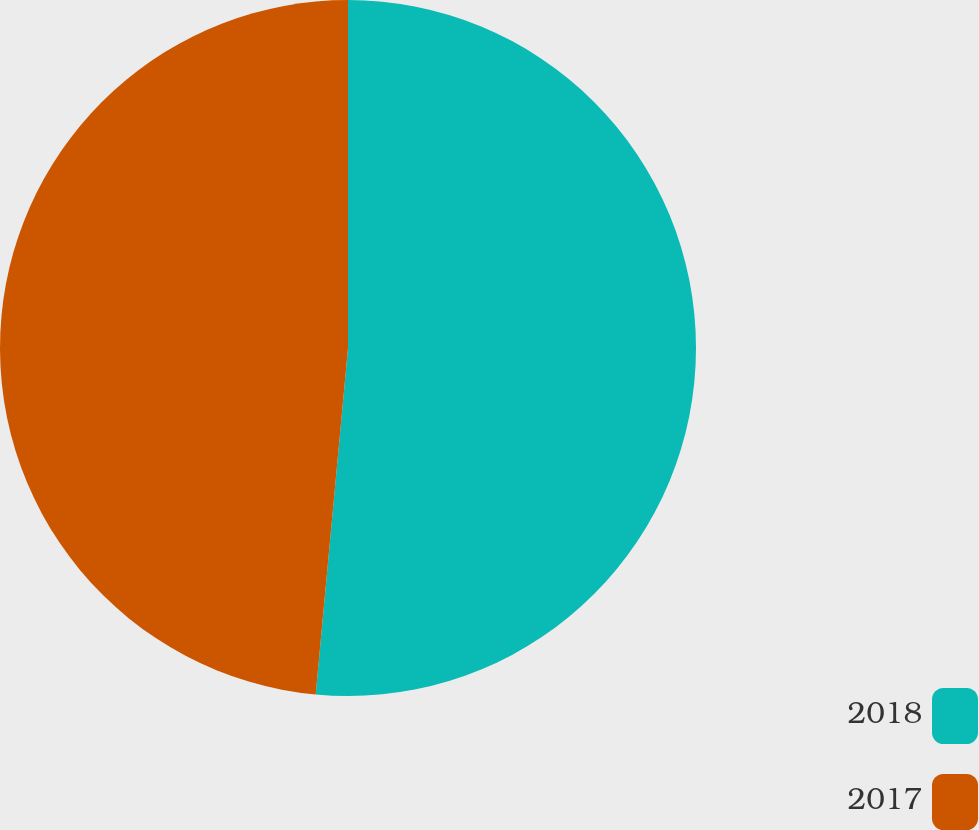Convert chart to OTSL. <chart><loc_0><loc_0><loc_500><loc_500><pie_chart><fcel>2018<fcel>2017<nl><fcel>51.48%<fcel>48.52%<nl></chart> 